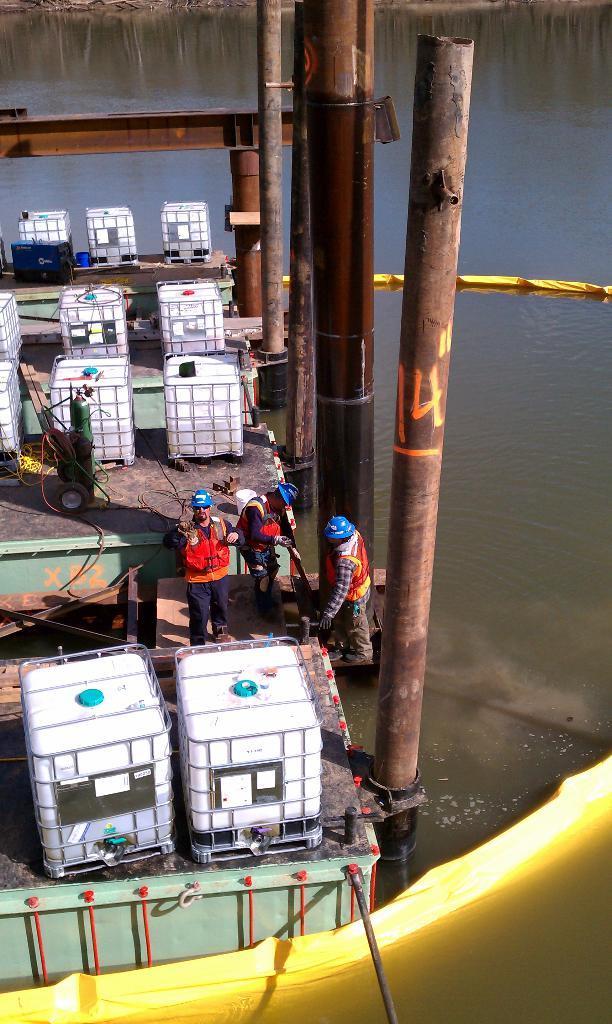Please provide a concise description of this image. In this image we can see a group of people standing. We can also see some containers, pipes and some devices placed on the surface. We can also see some metal poles and a barrier on a water body. 